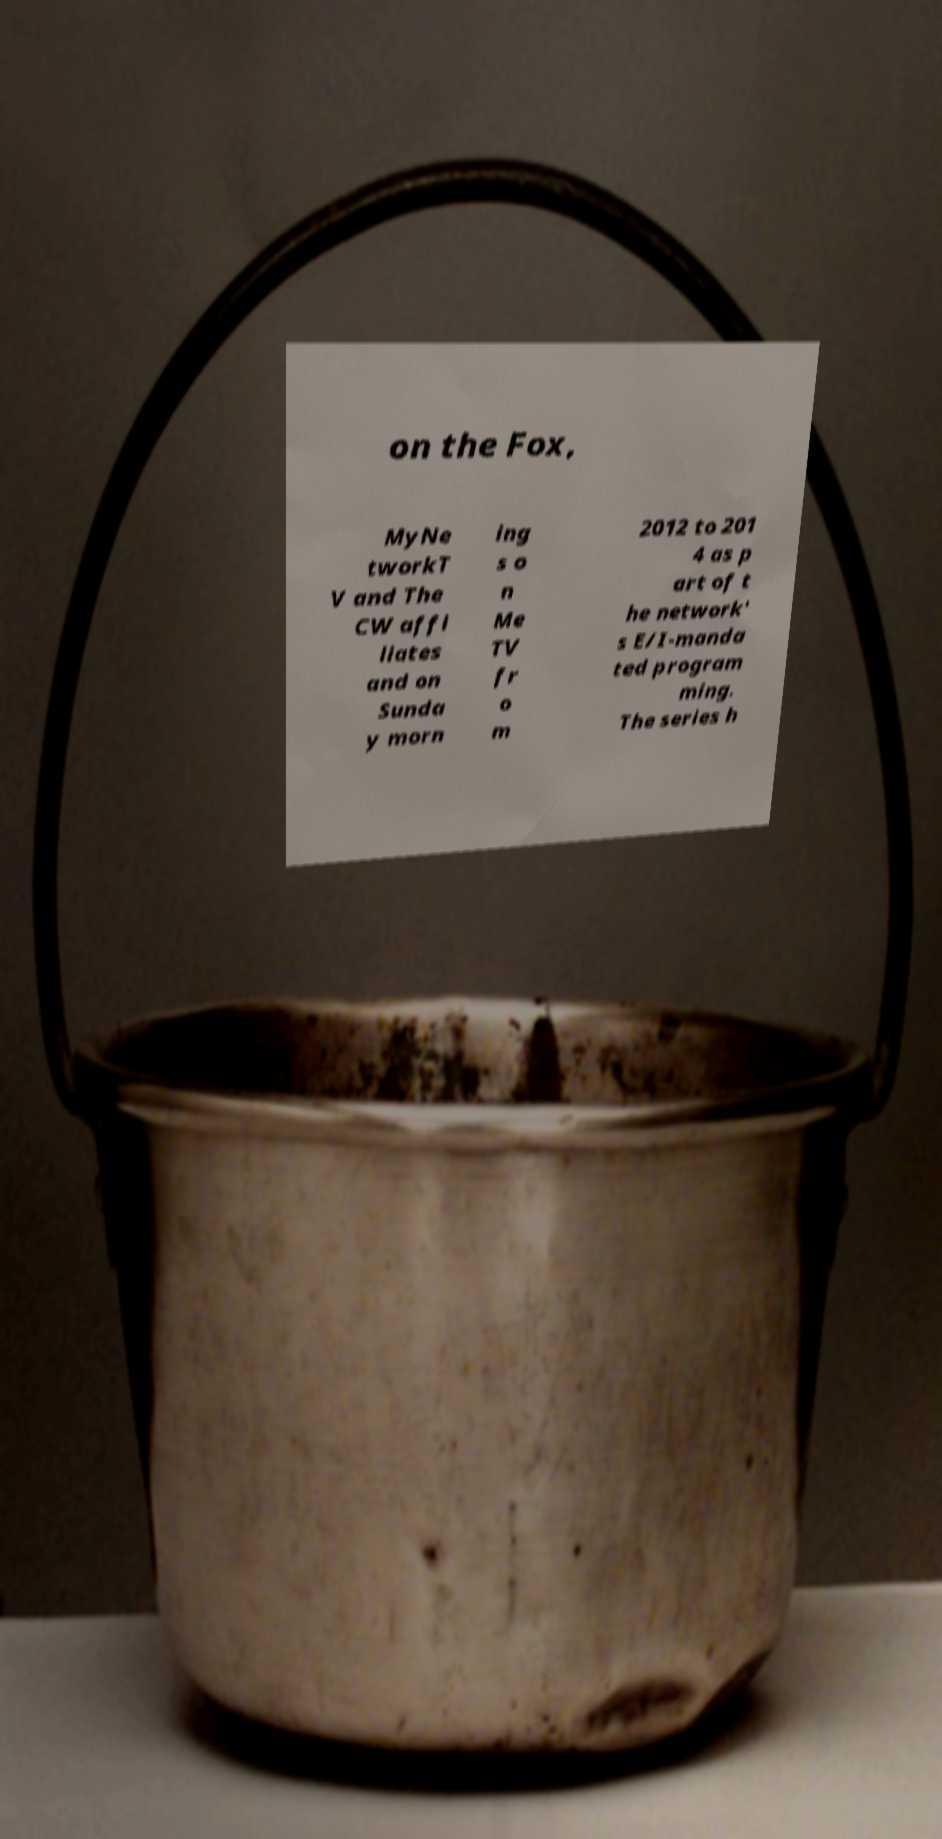For documentation purposes, I need the text within this image transcribed. Could you provide that? on the Fox, MyNe tworkT V and The CW affi liates and on Sunda y morn ing s o n Me TV fr o m 2012 to 201 4 as p art of t he network' s E/I-manda ted program ming. The series h 